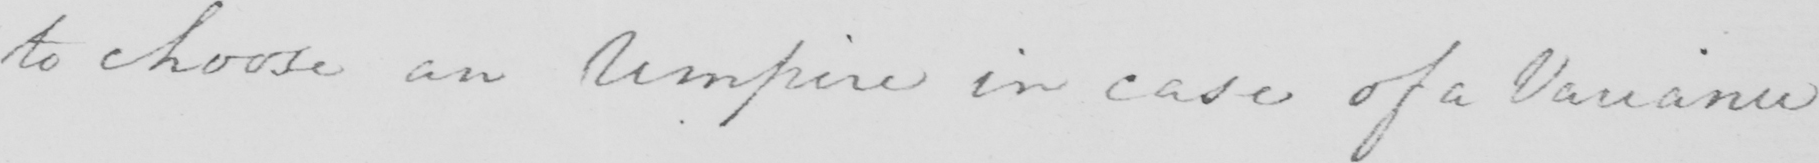Can you read and transcribe this handwriting? to choose an Umpire in case of a Variance 